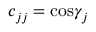<formula> <loc_0><loc_0><loc_500><loc_500>c _ { j j } = \cos \gamma _ { j }</formula> 